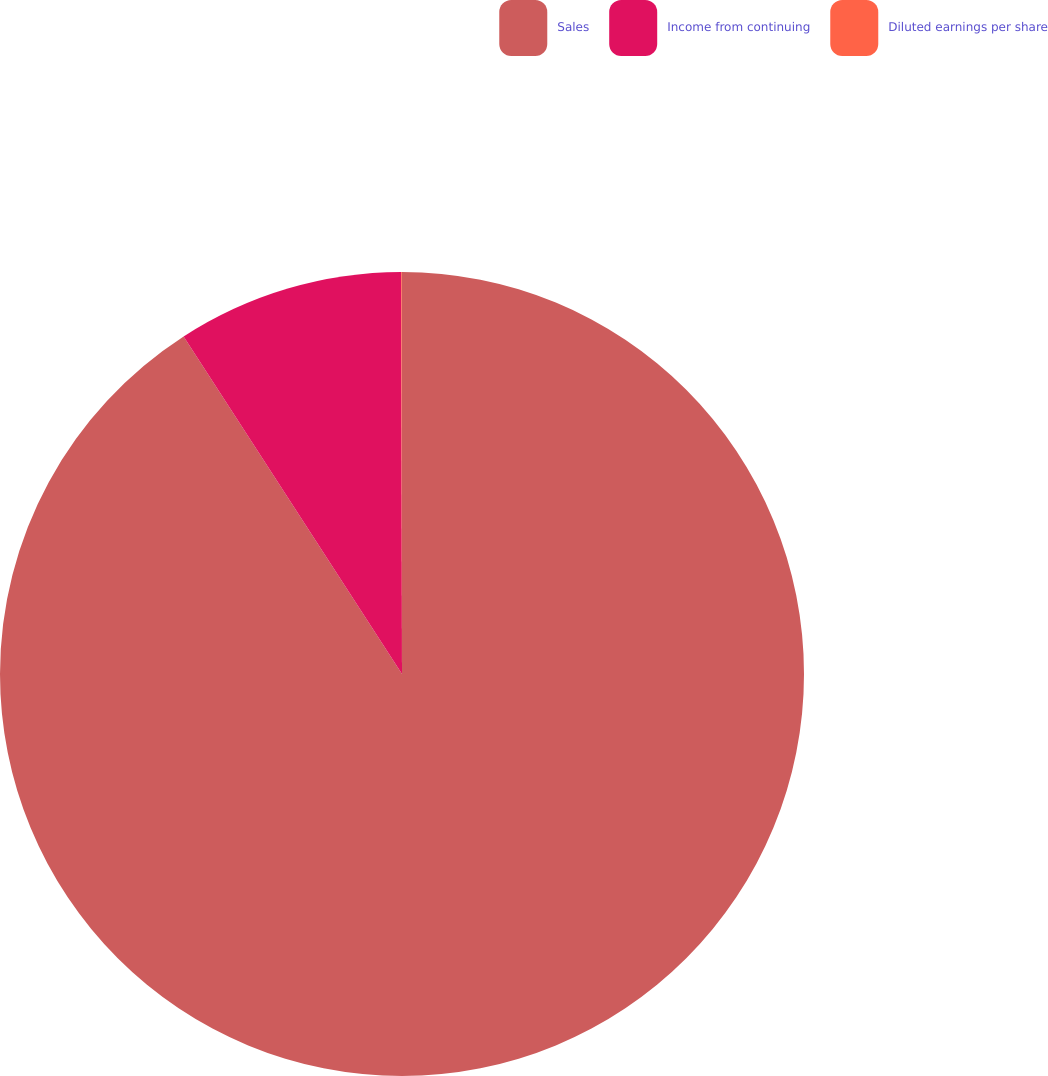Convert chart to OTSL. <chart><loc_0><loc_0><loc_500><loc_500><pie_chart><fcel>Sales<fcel>Income from continuing<fcel>Diluted earnings per share<nl><fcel>90.85%<fcel>9.11%<fcel>0.03%<nl></chart> 